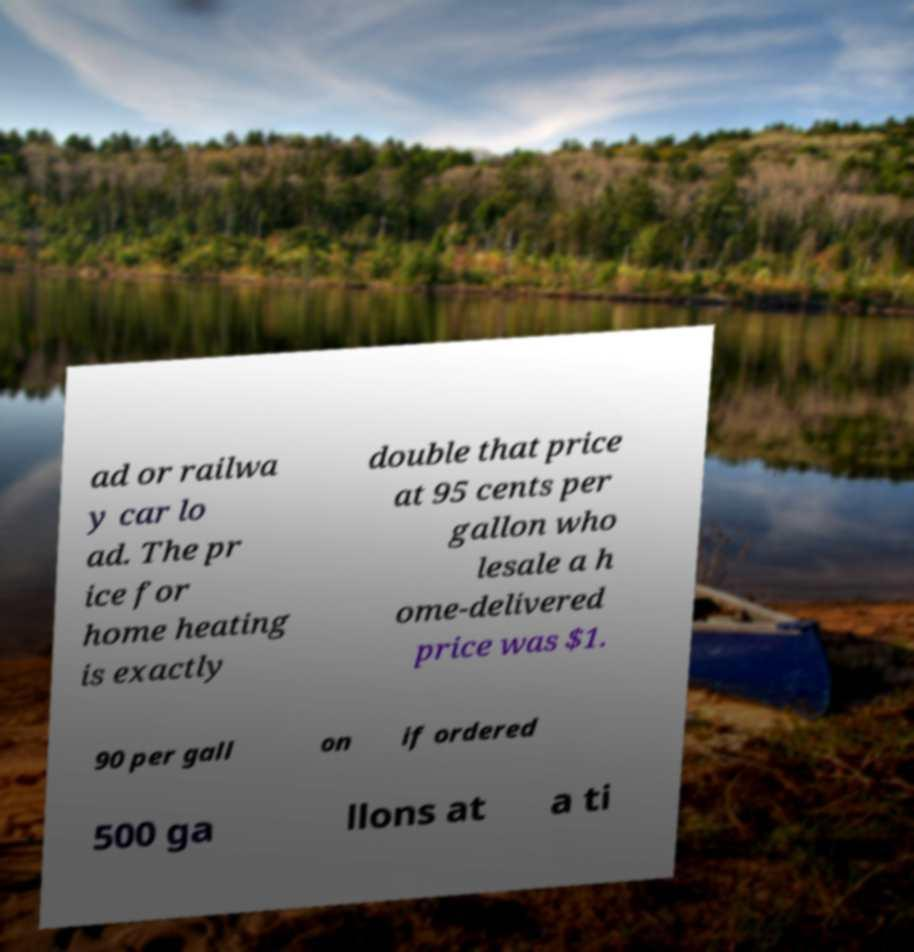What messages or text are displayed in this image? I need them in a readable, typed format. ad or railwa y car lo ad. The pr ice for home heating is exactly double that price at 95 cents per gallon who lesale a h ome-delivered price was $1. 90 per gall on if ordered 500 ga llons at a ti 